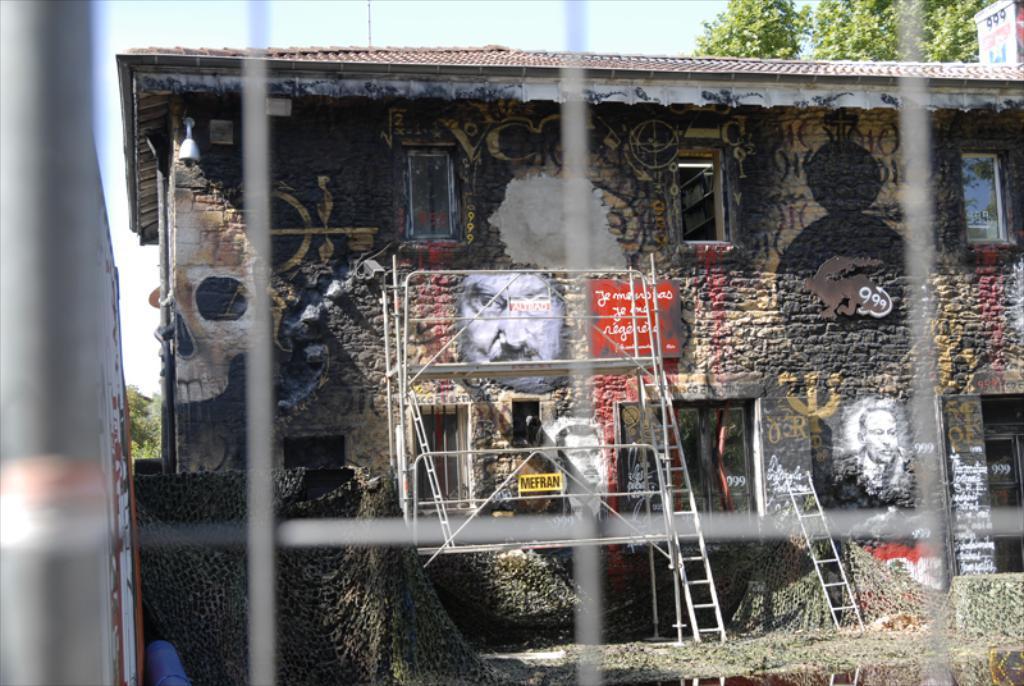In one or two sentences, can you explain what this image depicts? In this image there is a building and we can see paintings on the building. There are ladders. In the background there are trees and sky. In the foreground there is a mesh. We can see windows. 